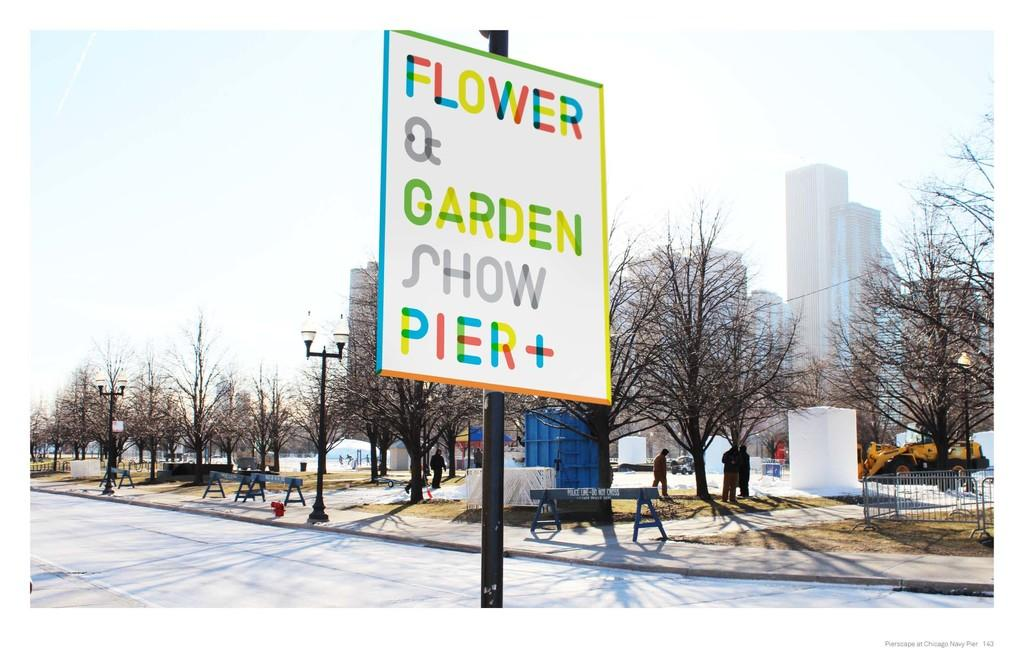Provide a one-sentence caption for the provided image. A colorful sign that says Flower and Garden Show Pier Plus. 